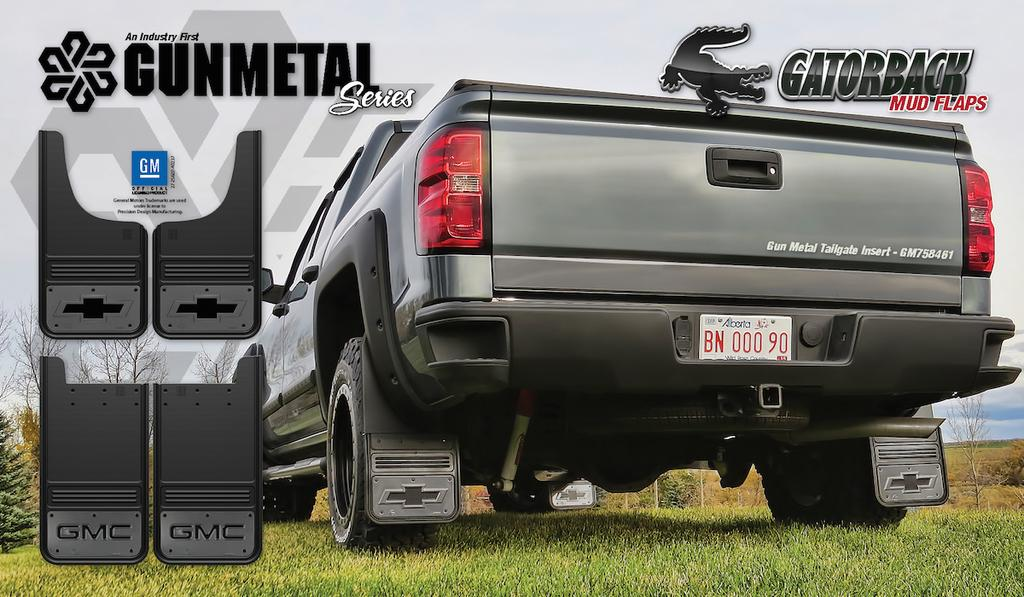What type of vehicle is in the picture? There is a silver van in the picture. Where is the van located? The van is parked on the grass. What phrase is written on the top of the van? The phrase "Gunmetal series" is written on the top of the van. How many crowns can be seen on the van in the image? There are no crowns present on the van in the image. What type of liquid is being poured from the van in the image? There is no liquid being poured from the van in the image. 